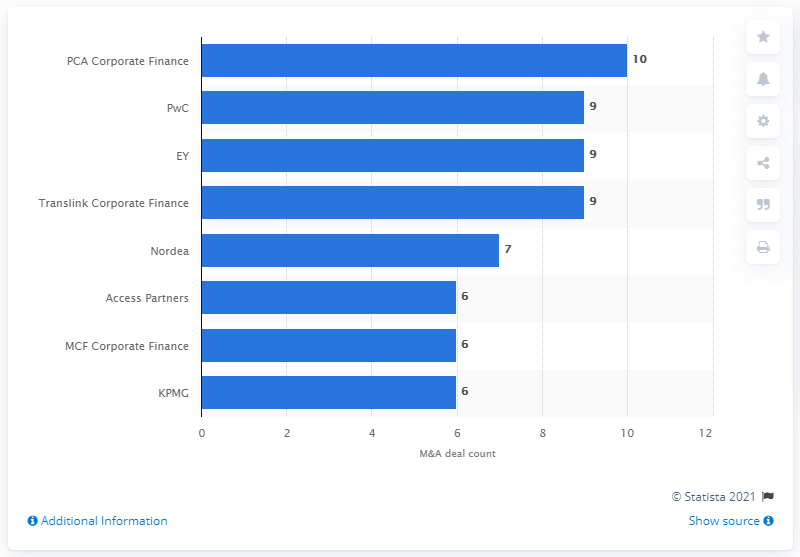Give some essential details in this illustration. PCA Corporate Finance was named as the leading advisor for M&A deals in Finland in 2016. 